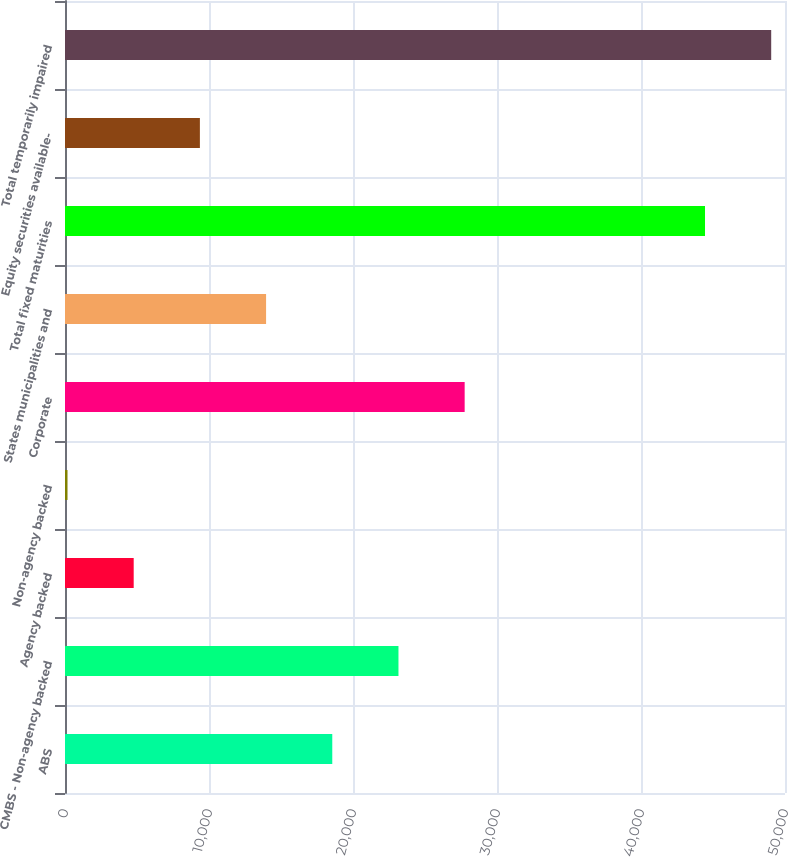<chart> <loc_0><loc_0><loc_500><loc_500><bar_chart><fcel>ABS<fcel>CMBS - Non-agency backed<fcel>Agency backed<fcel>Non-agency backed<fcel>Corporate<fcel>States municipalities and<fcel>Total fixed maturities<fcel>Equity securities available-<fcel>Total temporarily impaired<nl><fcel>18560.8<fcel>23157.5<fcel>4770.7<fcel>174<fcel>27754.2<fcel>13964.1<fcel>44445<fcel>9367.4<fcel>49041.7<nl></chart> 